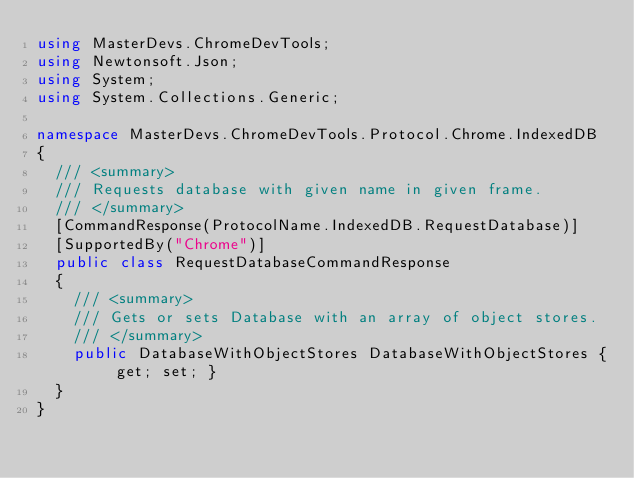<code> <loc_0><loc_0><loc_500><loc_500><_C#_>using MasterDevs.ChromeDevTools;
using Newtonsoft.Json;
using System;
using System.Collections.Generic;

namespace MasterDevs.ChromeDevTools.Protocol.Chrome.IndexedDB
{
	/// <summary>
	/// Requests database with given name in given frame.
	/// </summary>
	[CommandResponse(ProtocolName.IndexedDB.RequestDatabase)]
	[SupportedBy("Chrome")]
	public class RequestDatabaseCommandResponse
	{
		/// <summary>
		/// Gets or sets Database with an array of object stores.
		/// </summary>
		public DatabaseWithObjectStores DatabaseWithObjectStores { get; set; }
	}
}
</code> 